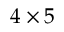Convert formula to latex. <formula><loc_0><loc_0><loc_500><loc_500>4 \times 5</formula> 